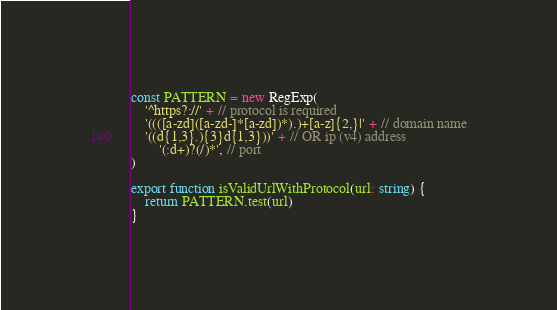<code> <loc_0><loc_0><loc_500><loc_500><_TypeScript_>const PATTERN = new RegExp(
    '^https?://' + // protocol is required
    '((([a-zd]([a-zd-]*[a-zd])*).)+[a-z]{2,}|' + // domain name
    '((d{1,3}.){3}d{1,3}))' + // OR ip (v4) address
        '(:d+)?(/)*', // port
)

export function isValidUrlWithProtocol(url: string) {
    return PATTERN.test(url)
}
</code> 